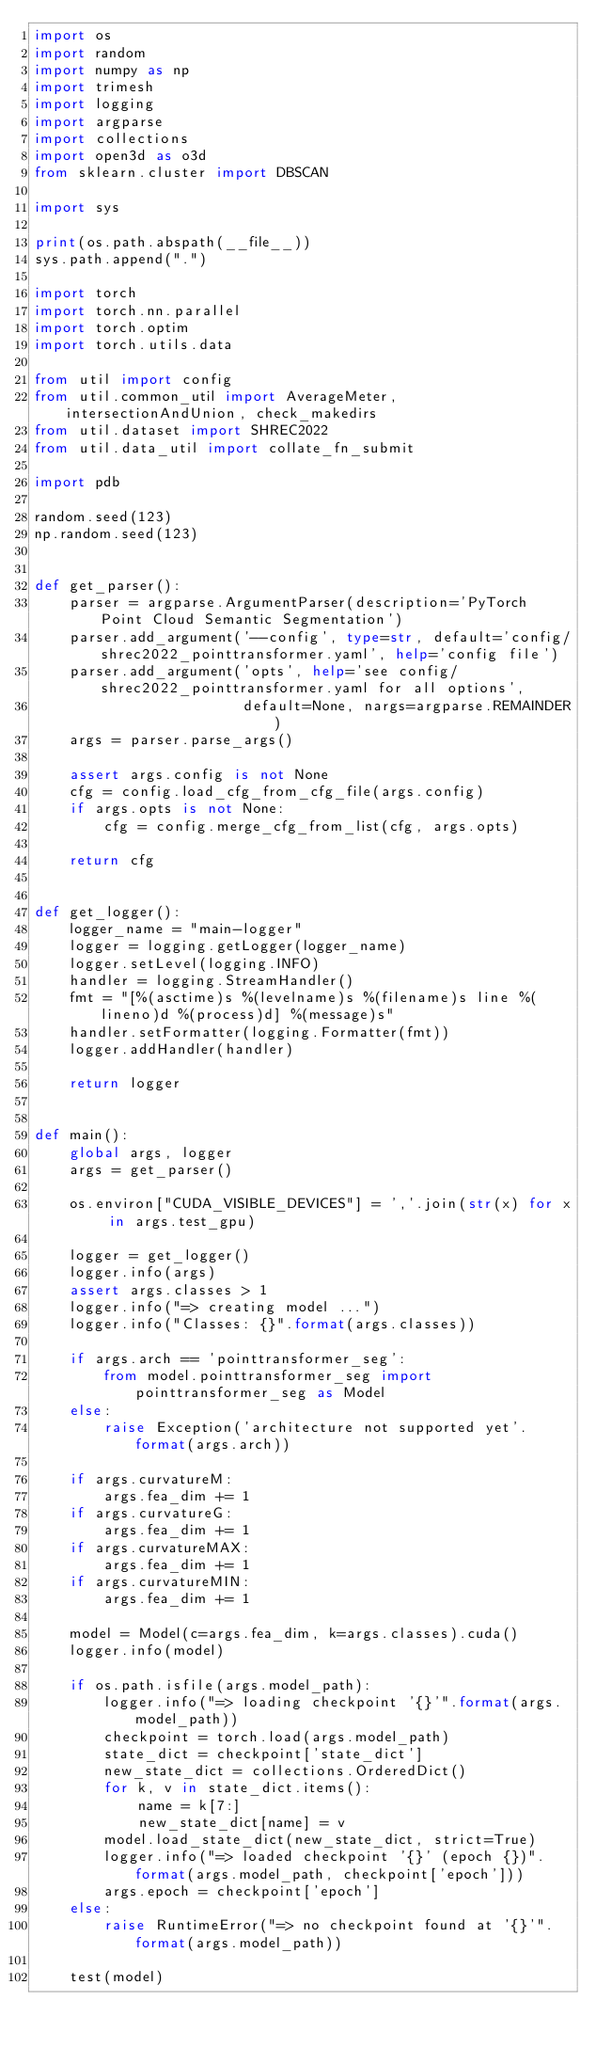Convert code to text. <code><loc_0><loc_0><loc_500><loc_500><_Python_>import os
import random
import numpy as np
import trimesh
import logging
import argparse
import collections
import open3d as o3d
from sklearn.cluster import DBSCAN

import sys

print(os.path.abspath(__file__))
sys.path.append(".")

import torch
import torch.nn.parallel
import torch.optim
import torch.utils.data

from util import config
from util.common_util import AverageMeter, intersectionAndUnion, check_makedirs
from util.dataset import SHREC2022
from util.data_util import collate_fn_submit

import pdb

random.seed(123)
np.random.seed(123)


def get_parser():
    parser = argparse.ArgumentParser(description='PyTorch Point Cloud Semantic Segmentation')
    parser.add_argument('--config', type=str, default='config/shrec2022_pointtransformer.yaml', help='config file')
    parser.add_argument('opts', help='see config/shrec2022_pointtransformer.yaml for all options',
                        default=None, nargs=argparse.REMAINDER)
    args = parser.parse_args()

    assert args.config is not None
    cfg = config.load_cfg_from_cfg_file(args.config)
    if args.opts is not None:
        cfg = config.merge_cfg_from_list(cfg, args.opts)

    return cfg


def get_logger():
    logger_name = "main-logger"
    logger = logging.getLogger(logger_name)
    logger.setLevel(logging.INFO)
    handler = logging.StreamHandler()
    fmt = "[%(asctime)s %(levelname)s %(filename)s line %(lineno)d %(process)d] %(message)s"
    handler.setFormatter(logging.Formatter(fmt))
    logger.addHandler(handler)

    return logger


def main():
    global args, logger
    args = get_parser()

    os.environ["CUDA_VISIBLE_DEVICES"] = ','.join(str(x) for x in args.test_gpu)

    logger = get_logger()
    logger.info(args)
    assert args.classes > 1
    logger.info("=> creating model ...")
    logger.info("Classes: {}".format(args.classes))

    if args.arch == 'pointtransformer_seg':
        from model.pointtransformer_seg import pointtransformer_seg as Model
    else:
        raise Exception('architecture not supported yet'.format(args.arch))

    if args.curvatureM:
        args.fea_dim += 1
    if args.curvatureG:
        args.fea_dim += 1
    if args.curvatureMAX:
        args.fea_dim += 1
    if args.curvatureMIN:
        args.fea_dim += 1

    model = Model(c=args.fea_dim, k=args.classes).cuda()
    logger.info(model)

    if os.path.isfile(args.model_path):
        logger.info("=> loading checkpoint '{}'".format(args.model_path))
        checkpoint = torch.load(args.model_path)
        state_dict = checkpoint['state_dict']
        new_state_dict = collections.OrderedDict()
        for k, v in state_dict.items():
            name = k[7:]
            new_state_dict[name] = v
        model.load_state_dict(new_state_dict, strict=True)
        logger.info("=> loaded checkpoint '{}' (epoch {})".format(args.model_path, checkpoint['epoch']))
        args.epoch = checkpoint['epoch']
    else:
        raise RuntimeError("=> no checkpoint found at '{}'".format(args.model_path))

    test(model)

</code> 